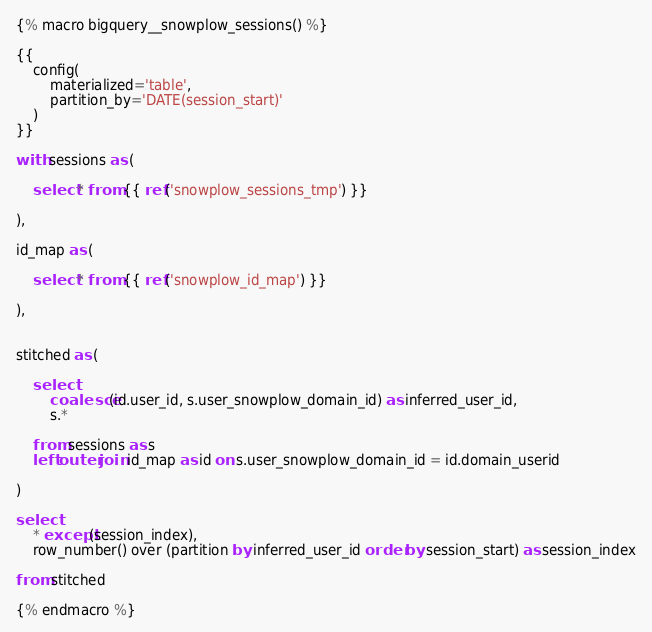<code> <loc_0><loc_0><loc_500><loc_500><_SQL_>
{% macro bigquery__snowplow_sessions() %}

{{
    config(
        materialized='table',
        partition_by='DATE(session_start)'
    )
}}

with sessions as (

    select * from {{ ref('snowplow_sessions_tmp') }}

),

id_map as (

    select * from {{ ref('snowplow_id_map') }}

),


stitched as (

    select
        coalesce(id.user_id, s.user_snowplow_domain_id) as inferred_user_id,
        s.*

    from sessions as s
    left outer join id_map as id on s.user_snowplow_domain_id = id.domain_userid

)

select
    * except(session_index),
    row_number() over (partition by inferred_user_id order by session_start) as session_index

from stitched

{% endmacro %}
</code> 